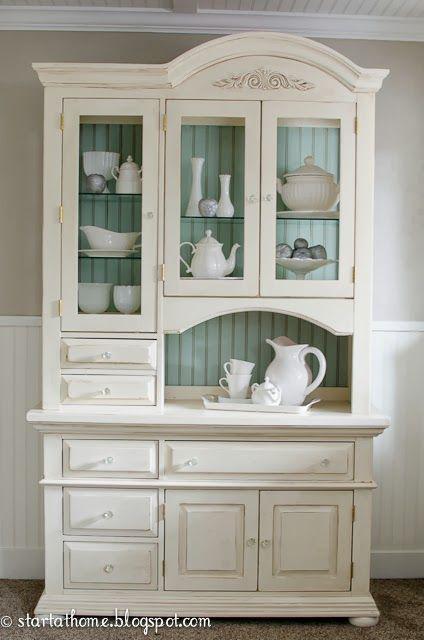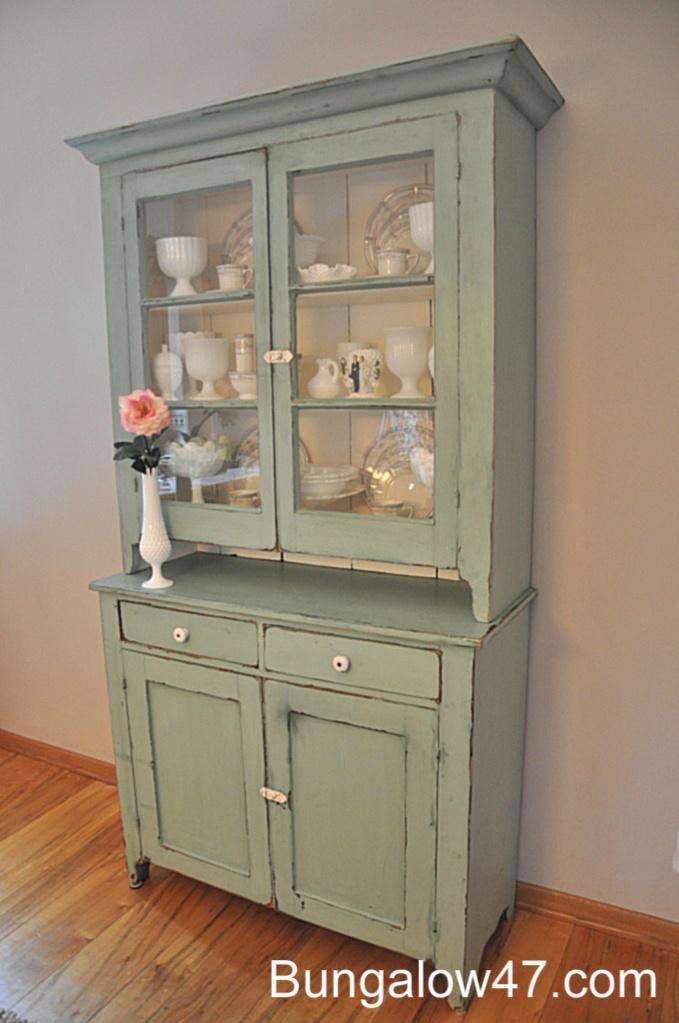The first image is the image on the left, the second image is the image on the right. Considering the images on both sides, is "The right image contains a turquoise wooden cabinet." valid? Answer yes or no. Yes. The first image is the image on the left, the second image is the image on the right. For the images shown, is this caption "Both cabinets are filled with crockery." true? Answer yes or no. Yes. 